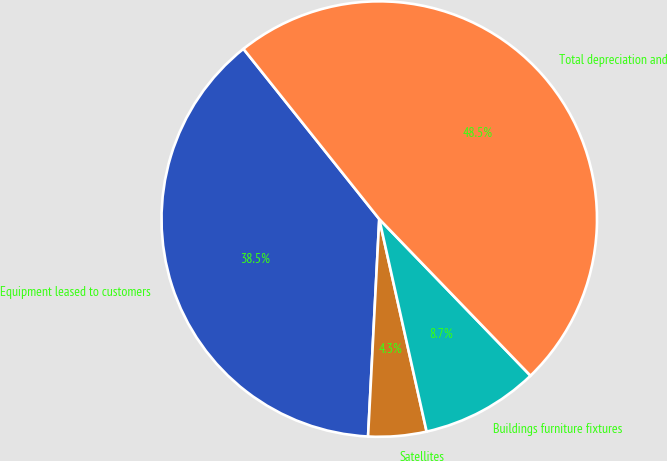Convert chart. <chart><loc_0><loc_0><loc_500><loc_500><pie_chart><fcel>Equipment leased to customers<fcel>Satellites<fcel>Buildings furniture fixtures<fcel>Total depreciation and<nl><fcel>38.46%<fcel>4.31%<fcel>8.73%<fcel>48.5%<nl></chart> 